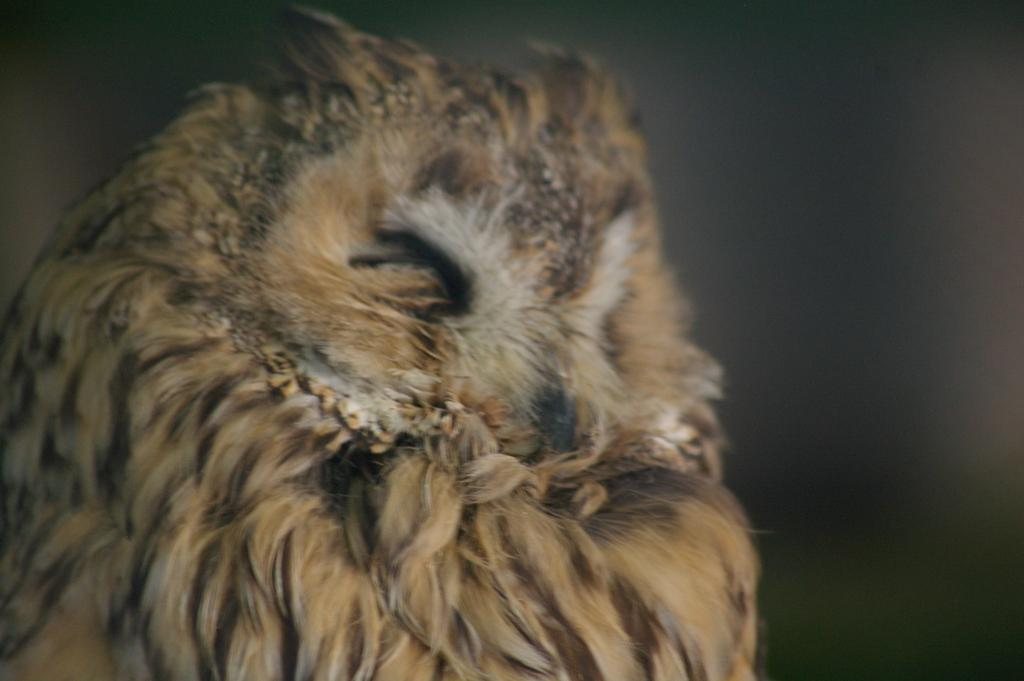What animal is featured in the image? There is an owl in the image. Can you describe the background of the image? The background of the image appears blurry. What type of account does the owl have in the image? There is no mention of an account in the image, as it features an owl and a blurry background. 